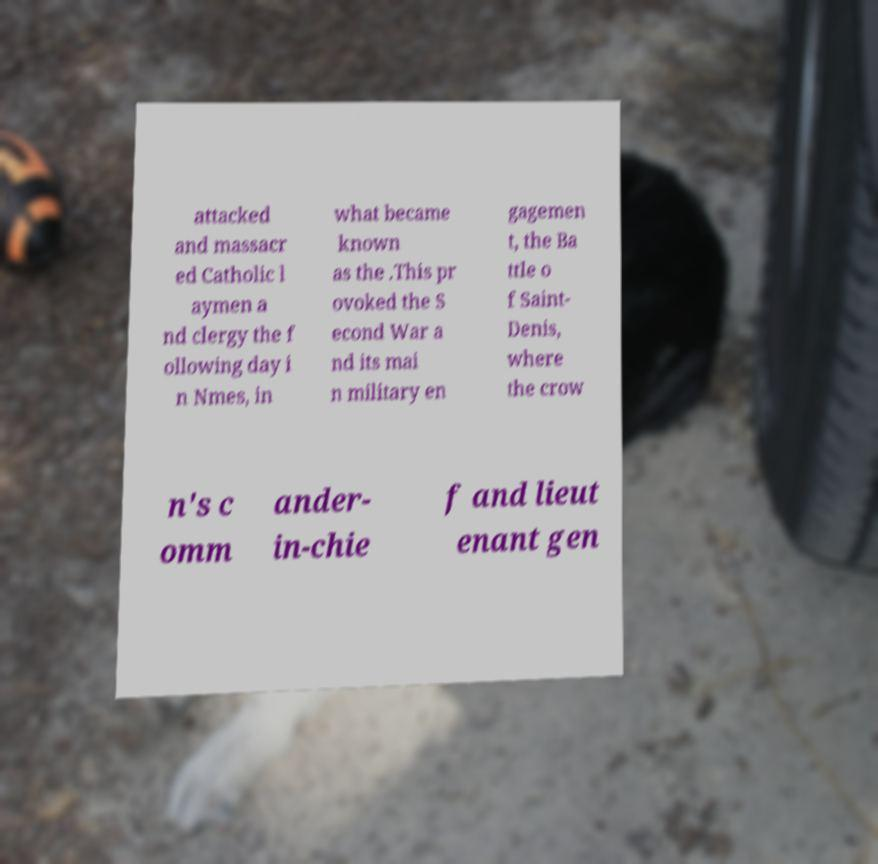I need the written content from this picture converted into text. Can you do that? attacked and massacr ed Catholic l aymen a nd clergy the f ollowing day i n Nmes, in what became known as the .This pr ovoked the S econd War a nd its mai n military en gagemen t, the Ba ttle o f Saint- Denis, where the crow n's c omm ander- in-chie f and lieut enant gen 